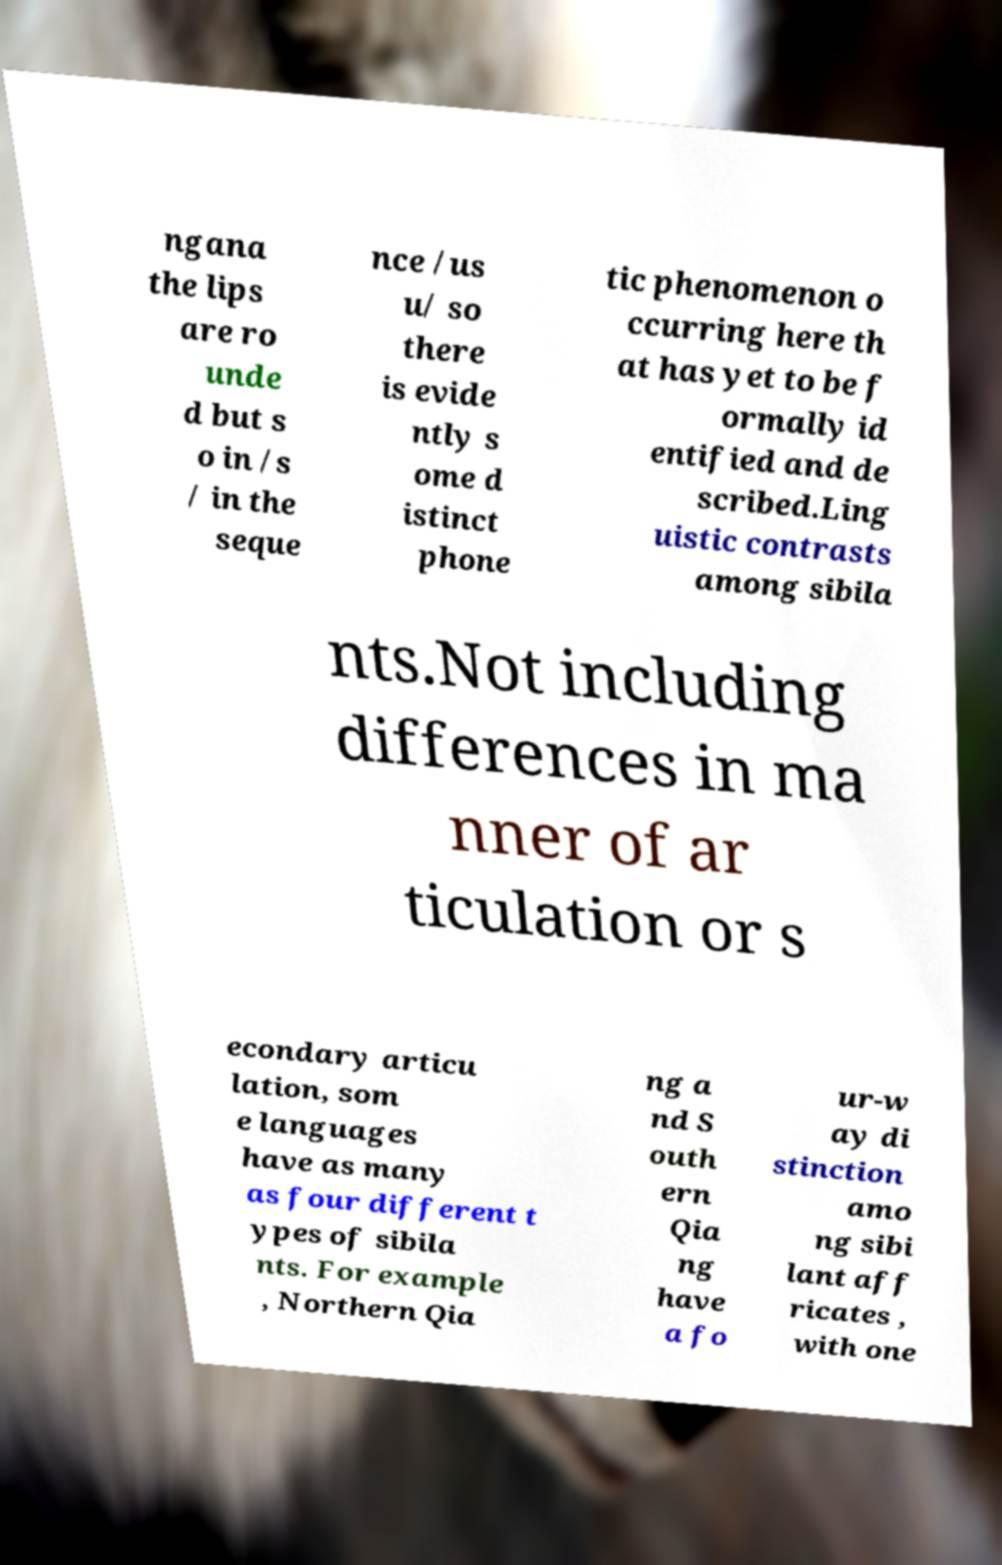Can you read and provide the text displayed in the image?This photo seems to have some interesting text. Can you extract and type it out for me? ngana the lips are ro unde d but s o in /s / in the seque nce /us u/ so there is evide ntly s ome d istinct phone tic phenomenon o ccurring here th at has yet to be f ormally id entified and de scribed.Ling uistic contrasts among sibila nts.Not including differences in ma nner of ar ticulation or s econdary articu lation, som e languages have as many as four different t ypes of sibila nts. For example , Northern Qia ng a nd S outh ern Qia ng have a fo ur-w ay di stinction amo ng sibi lant aff ricates , with one 